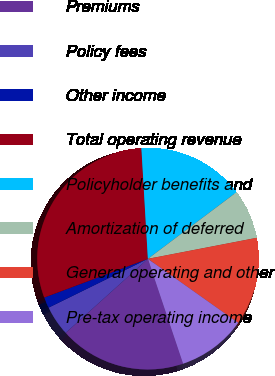Convert chart to OTSL. <chart><loc_0><loc_0><loc_500><loc_500><pie_chart><fcel>Premiums<fcel>Policy fees<fcel>Other income<fcel>Total operating revenue<fcel>Policyholder benefits and<fcel>Amortization of deferred<fcel>General operating and other<fcel>Pre-tax operating income<nl><fcel>18.49%<fcel>4.4%<fcel>1.58%<fcel>29.76%<fcel>15.67%<fcel>7.22%<fcel>12.85%<fcel>10.03%<nl></chart> 